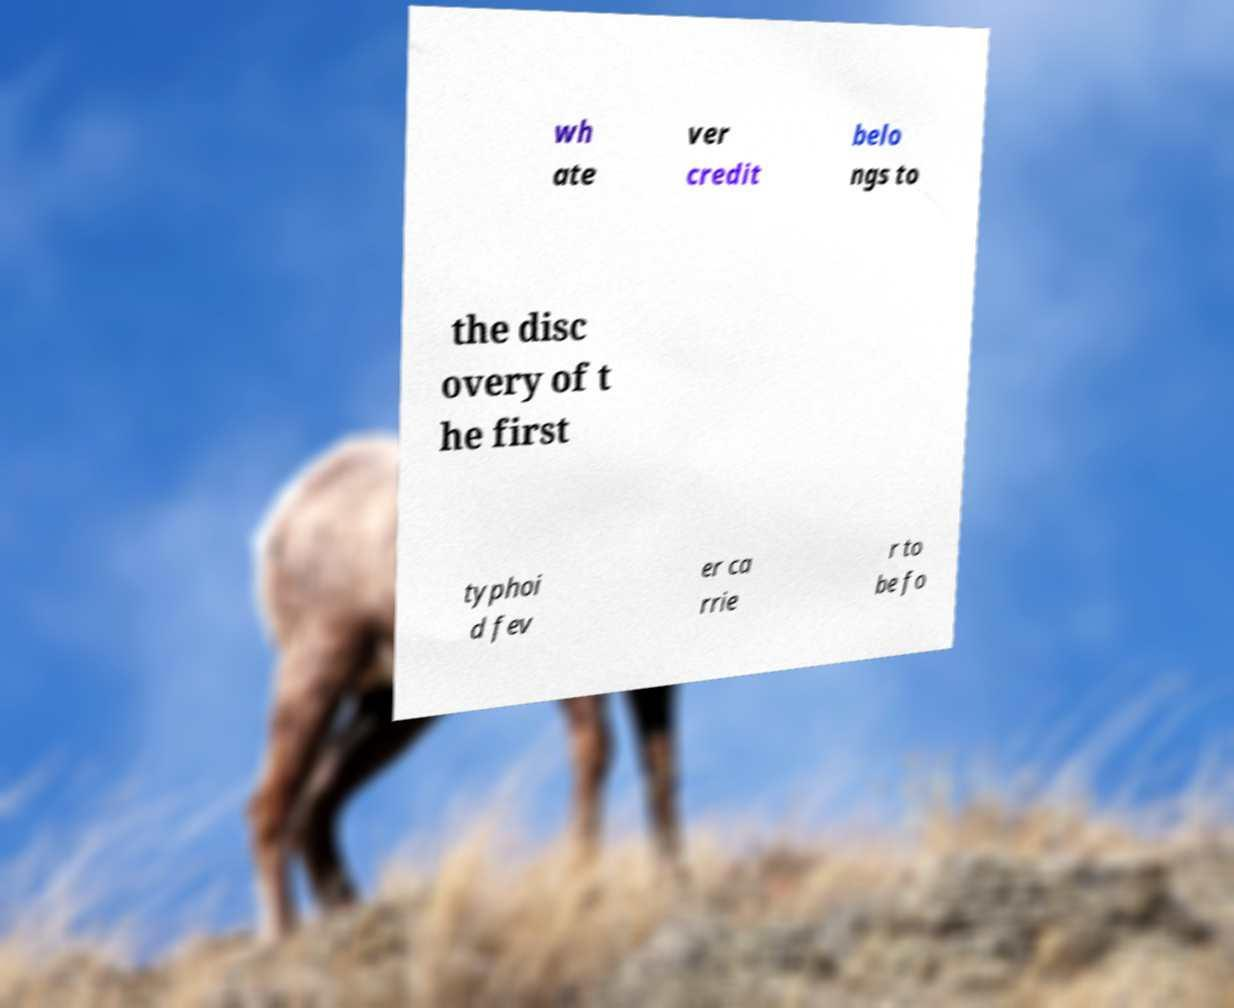I need the written content from this picture converted into text. Can you do that? wh ate ver credit belo ngs to the disc overy of t he first typhoi d fev er ca rrie r to be fo 